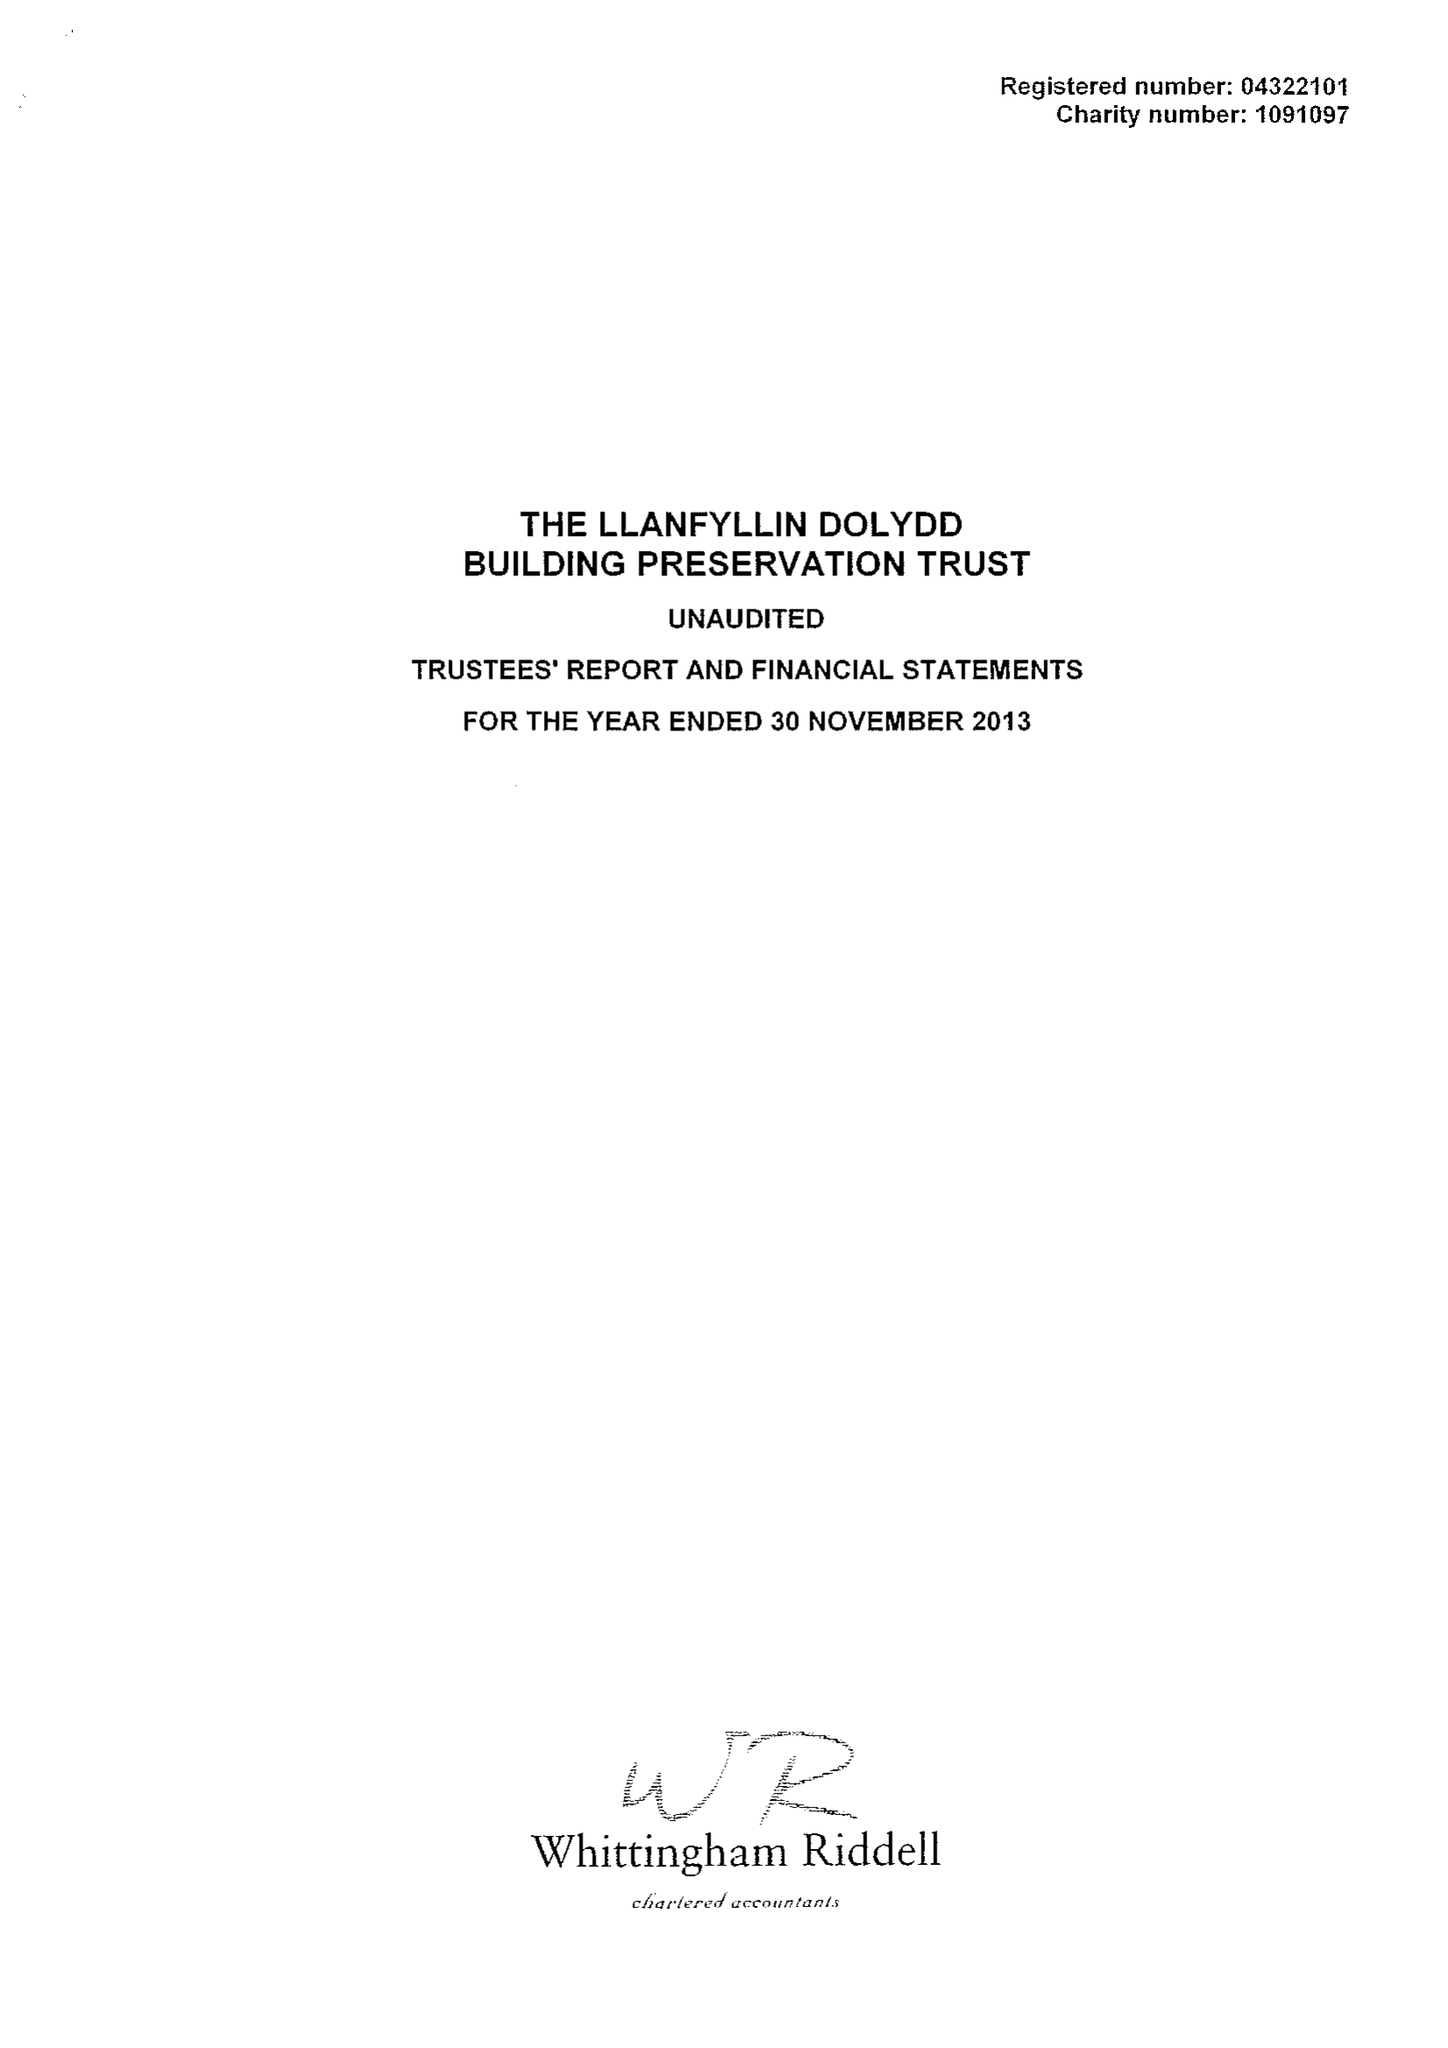What is the value for the address__post_town?
Answer the question using a single word or phrase. OSWESTRY 